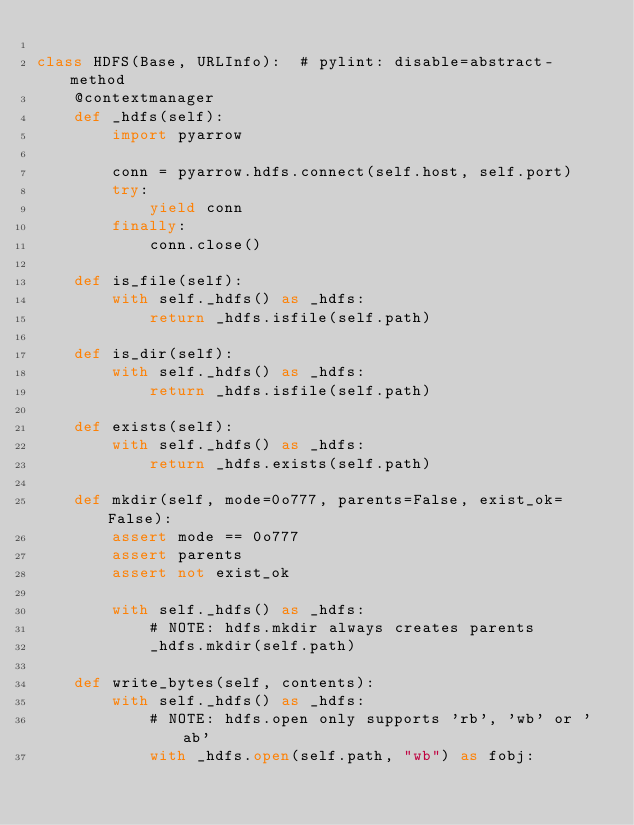<code> <loc_0><loc_0><loc_500><loc_500><_Python_>
class HDFS(Base, URLInfo):  # pylint: disable=abstract-method
    @contextmanager
    def _hdfs(self):
        import pyarrow

        conn = pyarrow.hdfs.connect(self.host, self.port)
        try:
            yield conn
        finally:
            conn.close()

    def is_file(self):
        with self._hdfs() as _hdfs:
            return _hdfs.isfile(self.path)

    def is_dir(self):
        with self._hdfs() as _hdfs:
            return _hdfs.isfile(self.path)

    def exists(self):
        with self._hdfs() as _hdfs:
            return _hdfs.exists(self.path)

    def mkdir(self, mode=0o777, parents=False, exist_ok=False):
        assert mode == 0o777
        assert parents
        assert not exist_ok

        with self._hdfs() as _hdfs:
            # NOTE: hdfs.mkdir always creates parents
            _hdfs.mkdir(self.path)

    def write_bytes(self, contents):
        with self._hdfs() as _hdfs:
            # NOTE: hdfs.open only supports 'rb', 'wb' or 'ab'
            with _hdfs.open(self.path, "wb") as fobj:</code> 